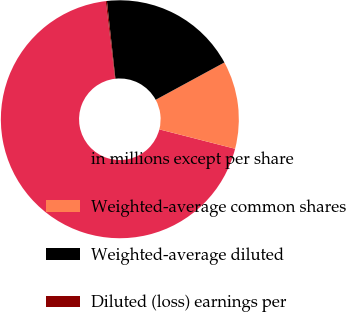<chart> <loc_0><loc_0><loc_500><loc_500><pie_chart><fcel>in millions except per share<fcel>Weighted-average common shares<fcel>Weighted-average diluted<fcel>Diluted (loss) earnings per<nl><fcel>69.12%<fcel>11.91%<fcel>18.81%<fcel>0.16%<nl></chart> 